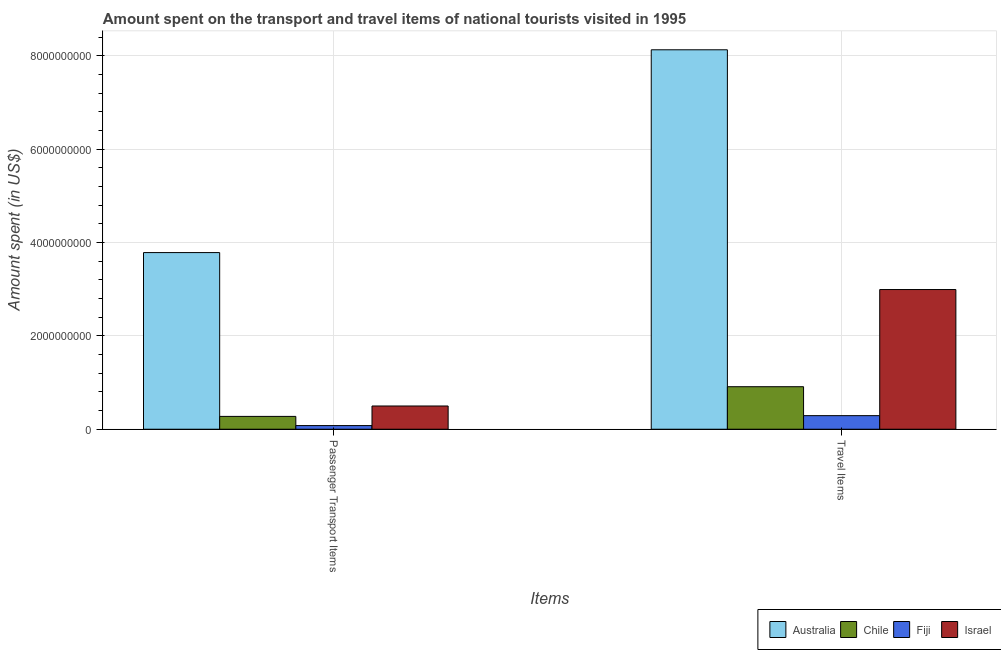How many different coloured bars are there?
Keep it short and to the point. 4. Are the number of bars per tick equal to the number of legend labels?
Provide a succinct answer. Yes. How many bars are there on the 1st tick from the left?
Your answer should be compact. 4. How many bars are there on the 2nd tick from the right?
Keep it short and to the point. 4. What is the label of the 2nd group of bars from the left?
Make the answer very short. Travel Items. What is the amount spent in travel items in Israel?
Ensure brevity in your answer.  2.99e+09. Across all countries, what is the maximum amount spent in travel items?
Keep it short and to the point. 8.13e+09. Across all countries, what is the minimum amount spent in travel items?
Make the answer very short. 2.91e+08. In which country was the amount spent on passenger transport items minimum?
Offer a terse response. Fiji. What is the total amount spent on passenger transport items in the graph?
Your answer should be compact. 4.64e+09. What is the difference between the amount spent in travel items in Chile and that in Fiji?
Keep it short and to the point. 6.20e+08. What is the difference between the amount spent in travel items in Fiji and the amount spent on passenger transport items in Chile?
Offer a very short reply. 1.60e+07. What is the average amount spent in travel items per country?
Offer a very short reply. 3.08e+09. What is the difference between the amount spent in travel items and amount spent on passenger transport items in Fiji?
Ensure brevity in your answer.  2.13e+08. What is the ratio of the amount spent on passenger transport items in Chile to that in Israel?
Your response must be concise. 0.55. What does the 3rd bar from the left in Passenger Transport Items represents?
Keep it short and to the point. Fiji. What does the 3rd bar from the right in Passenger Transport Items represents?
Your answer should be very brief. Chile. Are all the bars in the graph horizontal?
Ensure brevity in your answer.  No. Are the values on the major ticks of Y-axis written in scientific E-notation?
Make the answer very short. No. Does the graph contain any zero values?
Make the answer very short. No. How many legend labels are there?
Your response must be concise. 4. What is the title of the graph?
Provide a short and direct response. Amount spent on the transport and travel items of national tourists visited in 1995. Does "Fragile and conflict affected situations" appear as one of the legend labels in the graph?
Ensure brevity in your answer.  No. What is the label or title of the X-axis?
Give a very brief answer. Items. What is the label or title of the Y-axis?
Provide a short and direct response. Amount spent (in US$). What is the Amount spent (in US$) in Australia in Passenger Transport Items?
Offer a terse response. 3.78e+09. What is the Amount spent (in US$) in Chile in Passenger Transport Items?
Offer a very short reply. 2.75e+08. What is the Amount spent (in US$) in Fiji in Passenger Transport Items?
Give a very brief answer. 7.80e+07. What is the Amount spent (in US$) of Israel in Passenger Transport Items?
Offer a very short reply. 4.98e+08. What is the Amount spent (in US$) in Australia in Travel Items?
Ensure brevity in your answer.  8.13e+09. What is the Amount spent (in US$) of Chile in Travel Items?
Your response must be concise. 9.11e+08. What is the Amount spent (in US$) in Fiji in Travel Items?
Ensure brevity in your answer.  2.91e+08. What is the Amount spent (in US$) of Israel in Travel Items?
Ensure brevity in your answer.  2.99e+09. Across all Items, what is the maximum Amount spent (in US$) in Australia?
Your answer should be very brief. 8.13e+09. Across all Items, what is the maximum Amount spent (in US$) of Chile?
Offer a very short reply. 9.11e+08. Across all Items, what is the maximum Amount spent (in US$) in Fiji?
Your answer should be very brief. 2.91e+08. Across all Items, what is the maximum Amount spent (in US$) of Israel?
Keep it short and to the point. 2.99e+09. Across all Items, what is the minimum Amount spent (in US$) in Australia?
Make the answer very short. 3.78e+09. Across all Items, what is the minimum Amount spent (in US$) of Chile?
Offer a terse response. 2.75e+08. Across all Items, what is the minimum Amount spent (in US$) of Fiji?
Your answer should be very brief. 7.80e+07. Across all Items, what is the minimum Amount spent (in US$) of Israel?
Make the answer very short. 4.98e+08. What is the total Amount spent (in US$) of Australia in the graph?
Make the answer very short. 1.19e+1. What is the total Amount spent (in US$) in Chile in the graph?
Make the answer very short. 1.19e+09. What is the total Amount spent (in US$) of Fiji in the graph?
Offer a terse response. 3.69e+08. What is the total Amount spent (in US$) of Israel in the graph?
Offer a terse response. 3.49e+09. What is the difference between the Amount spent (in US$) in Australia in Passenger Transport Items and that in Travel Items?
Provide a short and direct response. -4.34e+09. What is the difference between the Amount spent (in US$) in Chile in Passenger Transport Items and that in Travel Items?
Provide a short and direct response. -6.36e+08. What is the difference between the Amount spent (in US$) of Fiji in Passenger Transport Items and that in Travel Items?
Offer a terse response. -2.13e+08. What is the difference between the Amount spent (in US$) in Israel in Passenger Transport Items and that in Travel Items?
Offer a very short reply. -2.50e+09. What is the difference between the Amount spent (in US$) in Australia in Passenger Transport Items and the Amount spent (in US$) in Chile in Travel Items?
Offer a terse response. 2.87e+09. What is the difference between the Amount spent (in US$) of Australia in Passenger Transport Items and the Amount spent (in US$) of Fiji in Travel Items?
Offer a very short reply. 3.49e+09. What is the difference between the Amount spent (in US$) in Australia in Passenger Transport Items and the Amount spent (in US$) in Israel in Travel Items?
Keep it short and to the point. 7.92e+08. What is the difference between the Amount spent (in US$) of Chile in Passenger Transport Items and the Amount spent (in US$) of Fiji in Travel Items?
Give a very brief answer. -1.60e+07. What is the difference between the Amount spent (in US$) in Chile in Passenger Transport Items and the Amount spent (in US$) in Israel in Travel Items?
Your answer should be compact. -2.72e+09. What is the difference between the Amount spent (in US$) in Fiji in Passenger Transport Items and the Amount spent (in US$) in Israel in Travel Items?
Offer a very short reply. -2.92e+09. What is the average Amount spent (in US$) in Australia per Items?
Provide a short and direct response. 5.96e+09. What is the average Amount spent (in US$) of Chile per Items?
Offer a very short reply. 5.93e+08. What is the average Amount spent (in US$) of Fiji per Items?
Provide a short and direct response. 1.84e+08. What is the average Amount spent (in US$) in Israel per Items?
Make the answer very short. 1.75e+09. What is the difference between the Amount spent (in US$) in Australia and Amount spent (in US$) in Chile in Passenger Transport Items?
Keep it short and to the point. 3.51e+09. What is the difference between the Amount spent (in US$) of Australia and Amount spent (in US$) of Fiji in Passenger Transport Items?
Your answer should be compact. 3.71e+09. What is the difference between the Amount spent (in US$) of Australia and Amount spent (in US$) of Israel in Passenger Transport Items?
Your answer should be compact. 3.29e+09. What is the difference between the Amount spent (in US$) of Chile and Amount spent (in US$) of Fiji in Passenger Transport Items?
Offer a very short reply. 1.97e+08. What is the difference between the Amount spent (in US$) in Chile and Amount spent (in US$) in Israel in Passenger Transport Items?
Offer a terse response. -2.23e+08. What is the difference between the Amount spent (in US$) of Fiji and Amount spent (in US$) of Israel in Passenger Transport Items?
Provide a succinct answer. -4.20e+08. What is the difference between the Amount spent (in US$) in Australia and Amount spent (in US$) in Chile in Travel Items?
Give a very brief answer. 7.22e+09. What is the difference between the Amount spent (in US$) in Australia and Amount spent (in US$) in Fiji in Travel Items?
Your answer should be compact. 7.84e+09. What is the difference between the Amount spent (in US$) in Australia and Amount spent (in US$) in Israel in Travel Items?
Make the answer very short. 5.14e+09. What is the difference between the Amount spent (in US$) of Chile and Amount spent (in US$) of Fiji in Travel Items?
Your answer should be compact. 6.20e+08. What is the difference between the Amount spent (in US$) of Chile and Amount spent (in US$) of Israel in Travel Items?
Your answer should be very brief. -2.08e+09. What is the difference between the Amount spent (in US$) in Fiji and Amount spent (in US$) in Israel in Travel Items?
Provide a succinct answer. -2.70e+09. What is the ratio of the Amount spent (in US$) of Australia in Passenger Transport Items to that in Travel Items?
Provide a short and direct response. 0.47. What is the ratio of the Amount spent (in US$) in Chile in Passenger Transport Items to that in Travel Items?
Your answer should be compact. 0.3. What is the ratio of the Amount spent (in US$) in Fiji in Passenger Transport Items to that in Travel Items?
Offer a very short reply. 0.27. What is the ratio of the Amount spent (in US$) in Israel in Passenger Transport Items to that in Travel Items?
Give a very brief answer. 0.17. What is the difference between the highest and the second highest Amount spent (in US$) of Australia?
Give a very brief answer. 4.34e+09. What is the difference between the highest and the second highest Amount spent (in US$) in Chile?
Offer a terse response. 6.36e+08. What is the difference between the highest and the second highest Amount spent (in US$) of Fiji?
Your answer should be compact. 2.13e+08. What is the difference between the highest and the second highest Amount spent (in US$) of Israel?
Ensure brevity in your answer.  2.50e+09. What is the difference between the highest and the lowest Amount spent (in US$) of Australia?
Offer a terse response. 4.34e+09. What is the difference between the highest and the lowest Amount spent (in US$) in Chile?
Your answer should be very brief. 6.36e+08. What is the difference between the highest and the lowest Amount spent (in US$) in Fiji?
Your response must be concise. 2.13e+08. What is the difference between the highest and the lowest Amount spent (in US$) in Israel?
Provide a succinct answer. 2.50e+09. 